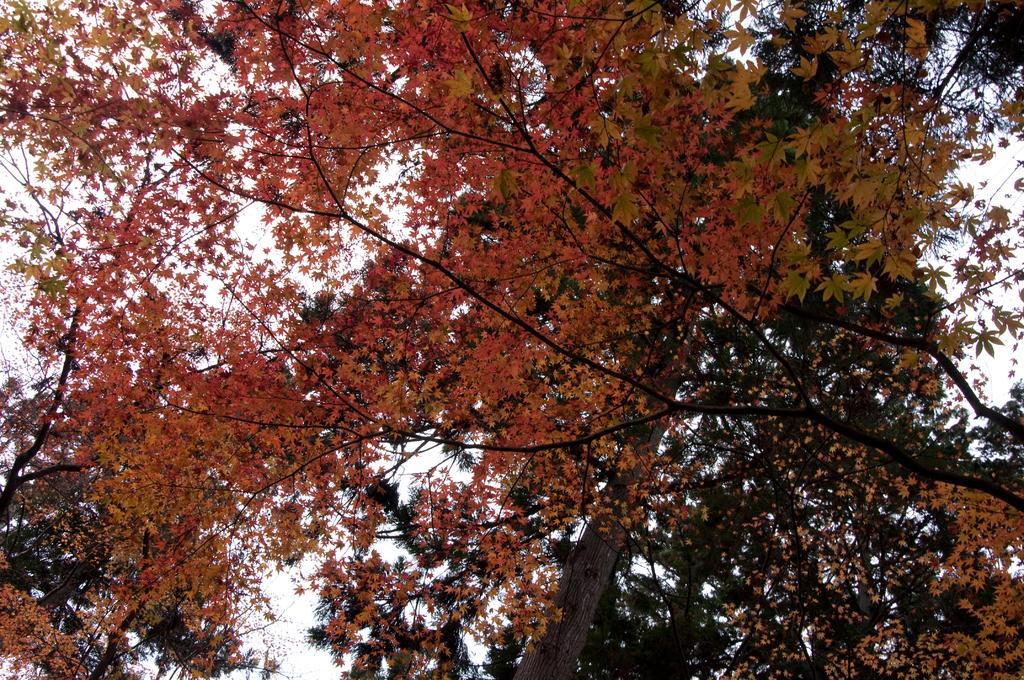In one or two sentences, can you explain what this image depicts? In this picture we can see a few trees throughout the image. 